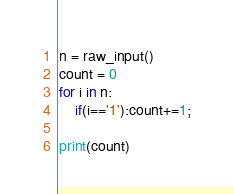Convert code to text. <code><loc_0><loc_0><loc_500><loc_500><_Python_>n = raw_input()
count = 0
for i in n:
    if(i=='1'):count+=1;

print(count)</code> 